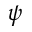<formula> <loc_0><loc_0><loc_500><loc_500>\psi</formula> 